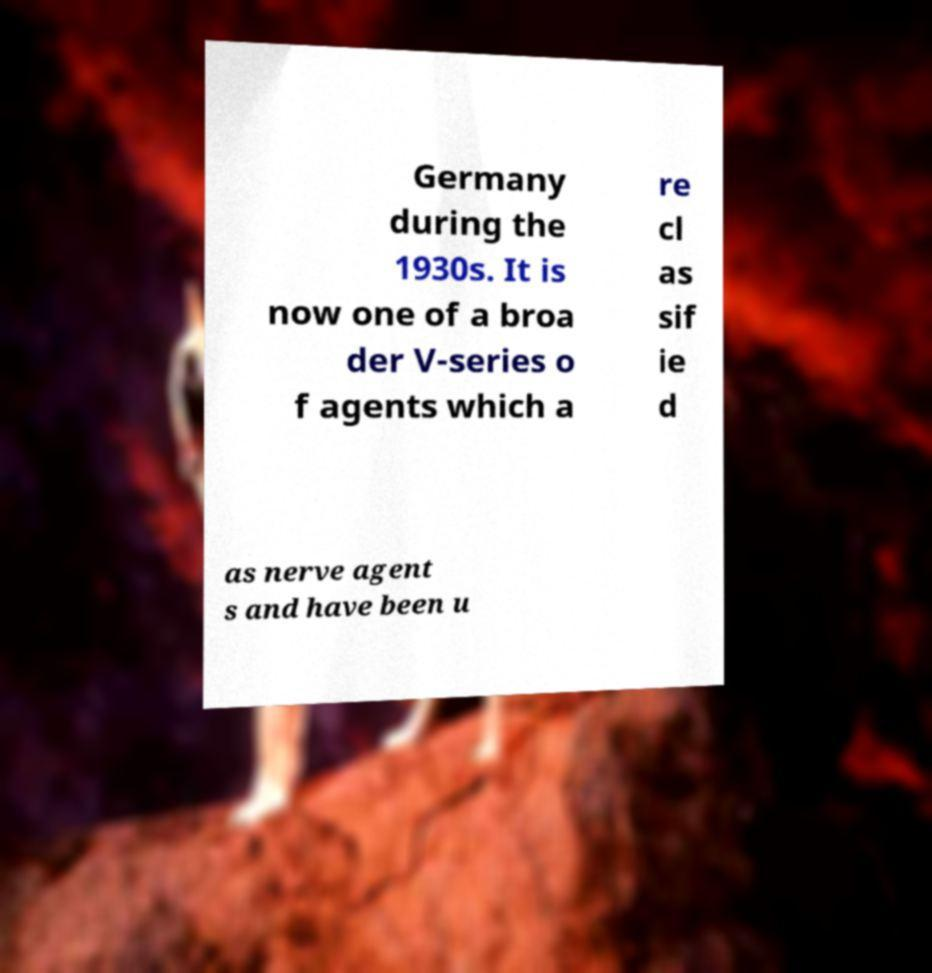There's text embedded in this image that I need extracted. Can you transcribe it verbatim? Germany during the 1930s. It is now one of a broa der V-series o f agents which a re cl as sif ie d as nerve agent s and have been u 